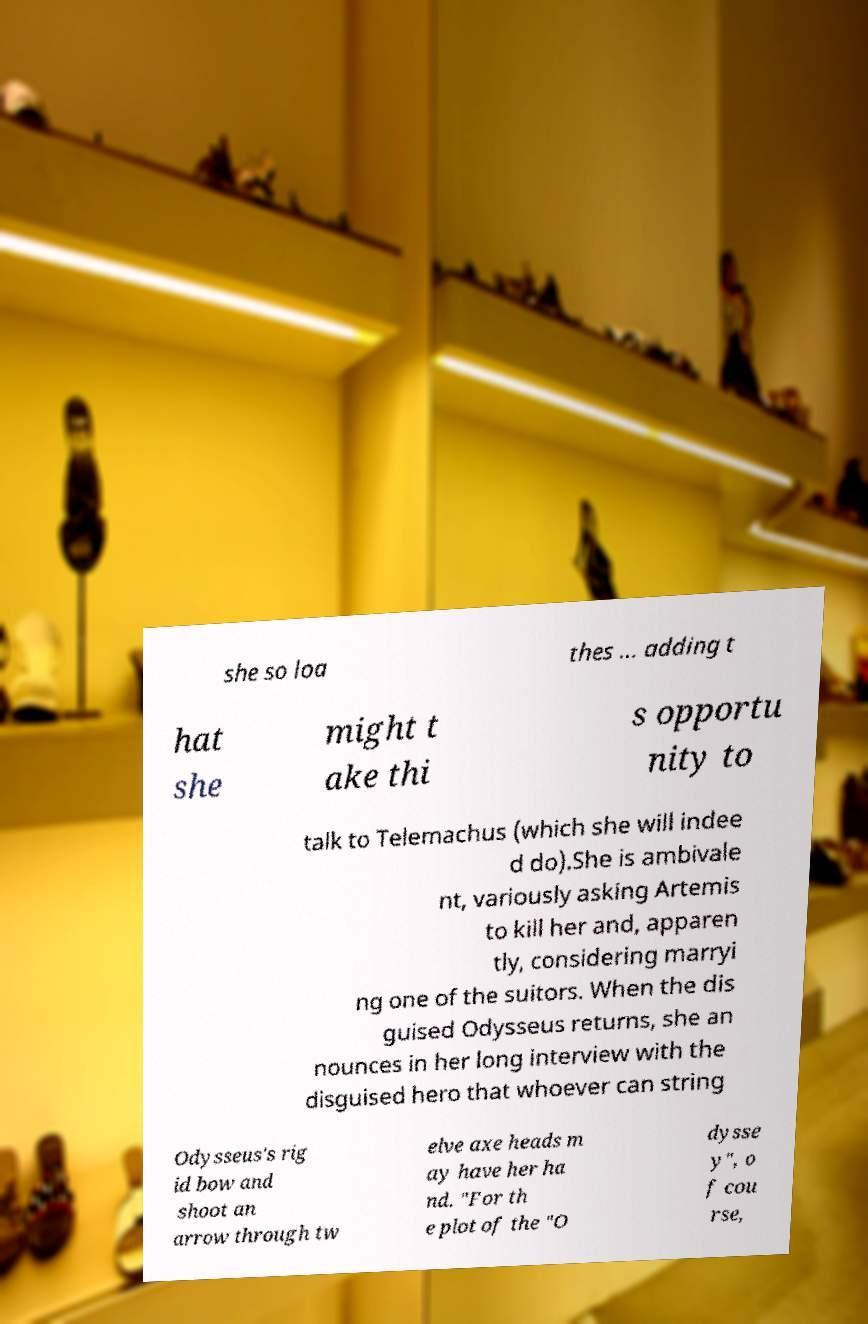Could you assist in decoding the text presented in this image and type it out clearly? she so loa thes ... adding t hat she might t ake thi s opportu nity to talk to Telemachus (which she will indee d do).She is ambivale nt, variously asking Artemis to kill her and, apparen tly, considering marryi ng one of the suitors. When the dis guised Odysseus returns, she an nounces in her long interview with the disguised hero that whoever can string Odysseus's rig id bow and shoot an arrow through tw elve axe heads m ay have her ha nd. "For th e plot of the "O dysse y", o f cou rse, 